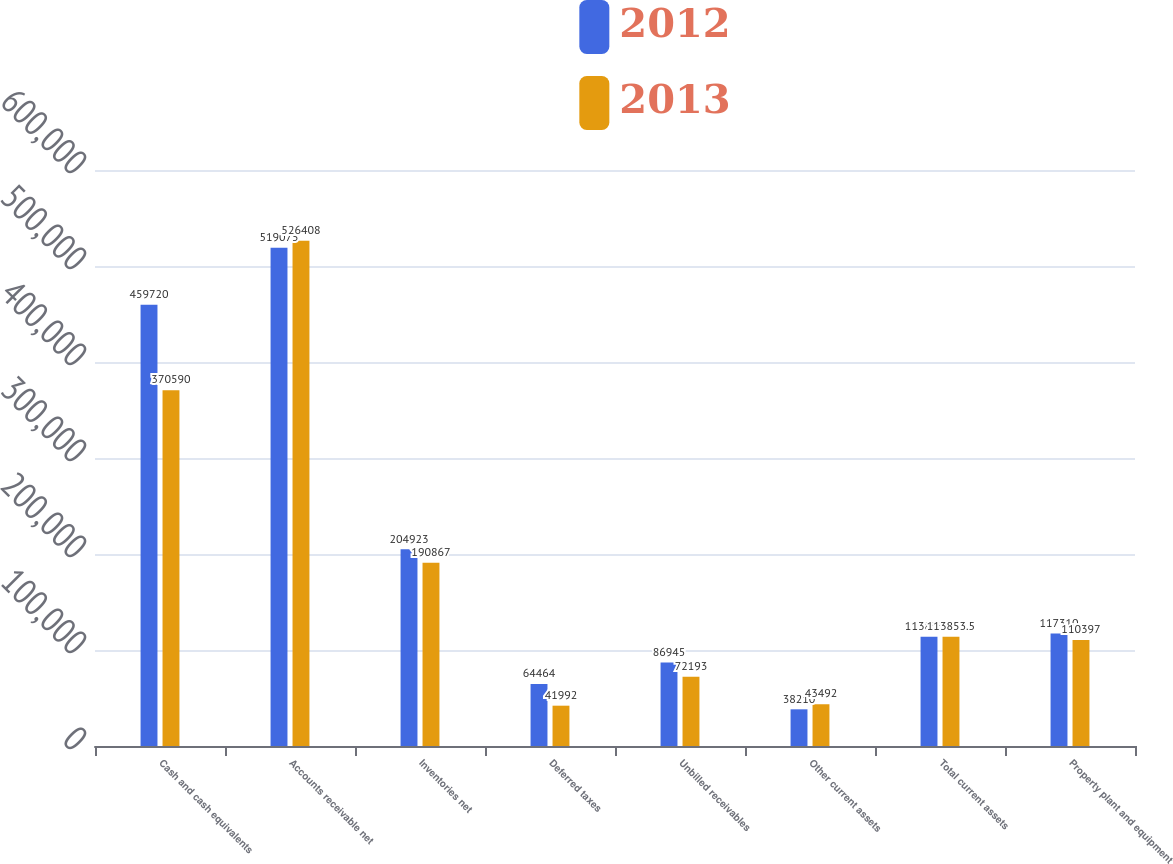Convert chart. <chart><loc_0><loc_0><loc_500><loc_500><stacked_bar_chart><ecel><fcel>Cash and cash equivalents<fcel>Accounts receivable net<fcel>Inventories net<fcel>Deferred taxes<fcel>Unbilled receivables<fcel>Other current assets<fcel>Total current assets<fcel>Property plant and equipment<nl><fcel>2012<fcel>459720<fcel>519075<fcel>204923<fcel>64464<fcel>86945<fcel>38210<fcel>113854<fcel>117310<nl><fcel>2013<fcel>370590<fcel>526408<fcel>190867<fcel>41992<fcel>72193<fcel>43492<fcel>113854<fcel>110397<nl></chart> 